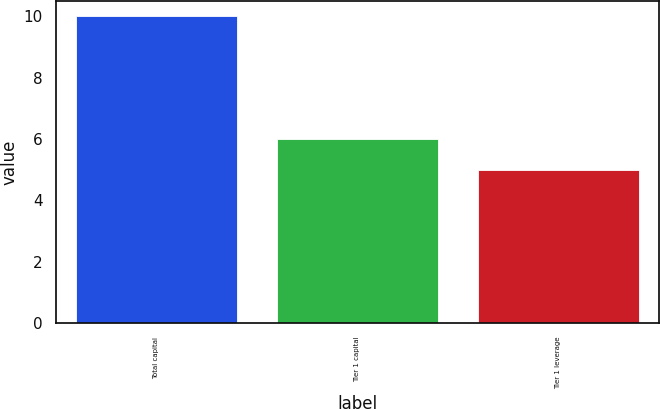Convert chart to OTSL. <chart><loc_0><loc_0><loc_500><loc_500><bar_chart><fcel>Total capital<fcel>Tier 1 capital<fcel>Tier 1 leverage<nl><fcel>10<fcel>6<fcel>5<nl></chart> 